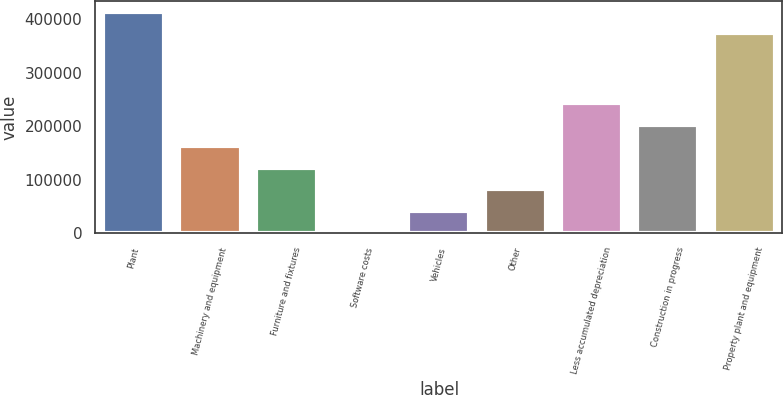<chart> <loc_0><loc_0><loc_500><loc_500><bar_chart><fcel>Plant<fcel>Machinery and equipment<fcel>Furniture and fixtures<fcel>Software costs<fcel>Vehicles<fcel>Other<fcel>Less accumulated depreciation<fcel>Construction in progress<fcel>Property plant and equipment<nl><fcel>413770<fcel>162253<fcel>122047<fcel>1429<fcel>41635<fcel>81841<fcel>242665<fcel>202459<fcel>373564<nl></chart> 